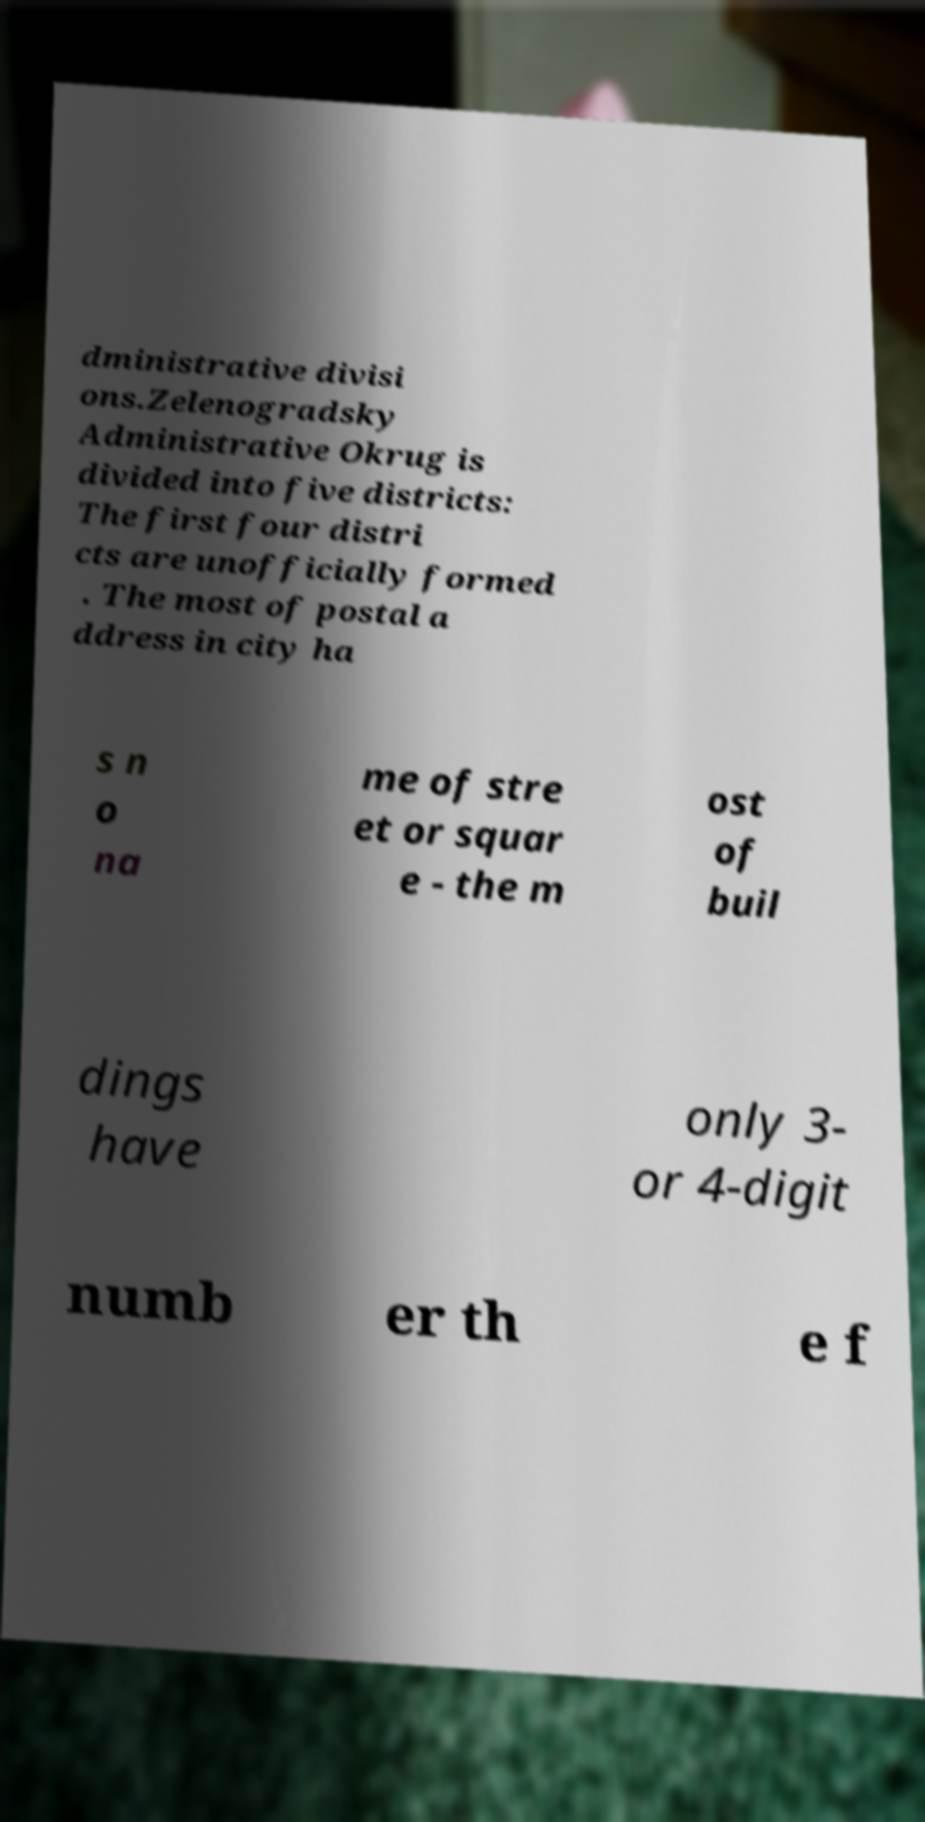I need the written content from this picture converted into text. Can you do that? dministrative divisi ons.Zelenogradsky Administrative Okrug is divided into five districts: The first four distri cts are unofficially formed . The most of postal a ddress in city ha s n o na me of stre et or squar e - the m ost of buil dings have only 3- or 4-digit numb er th e f 